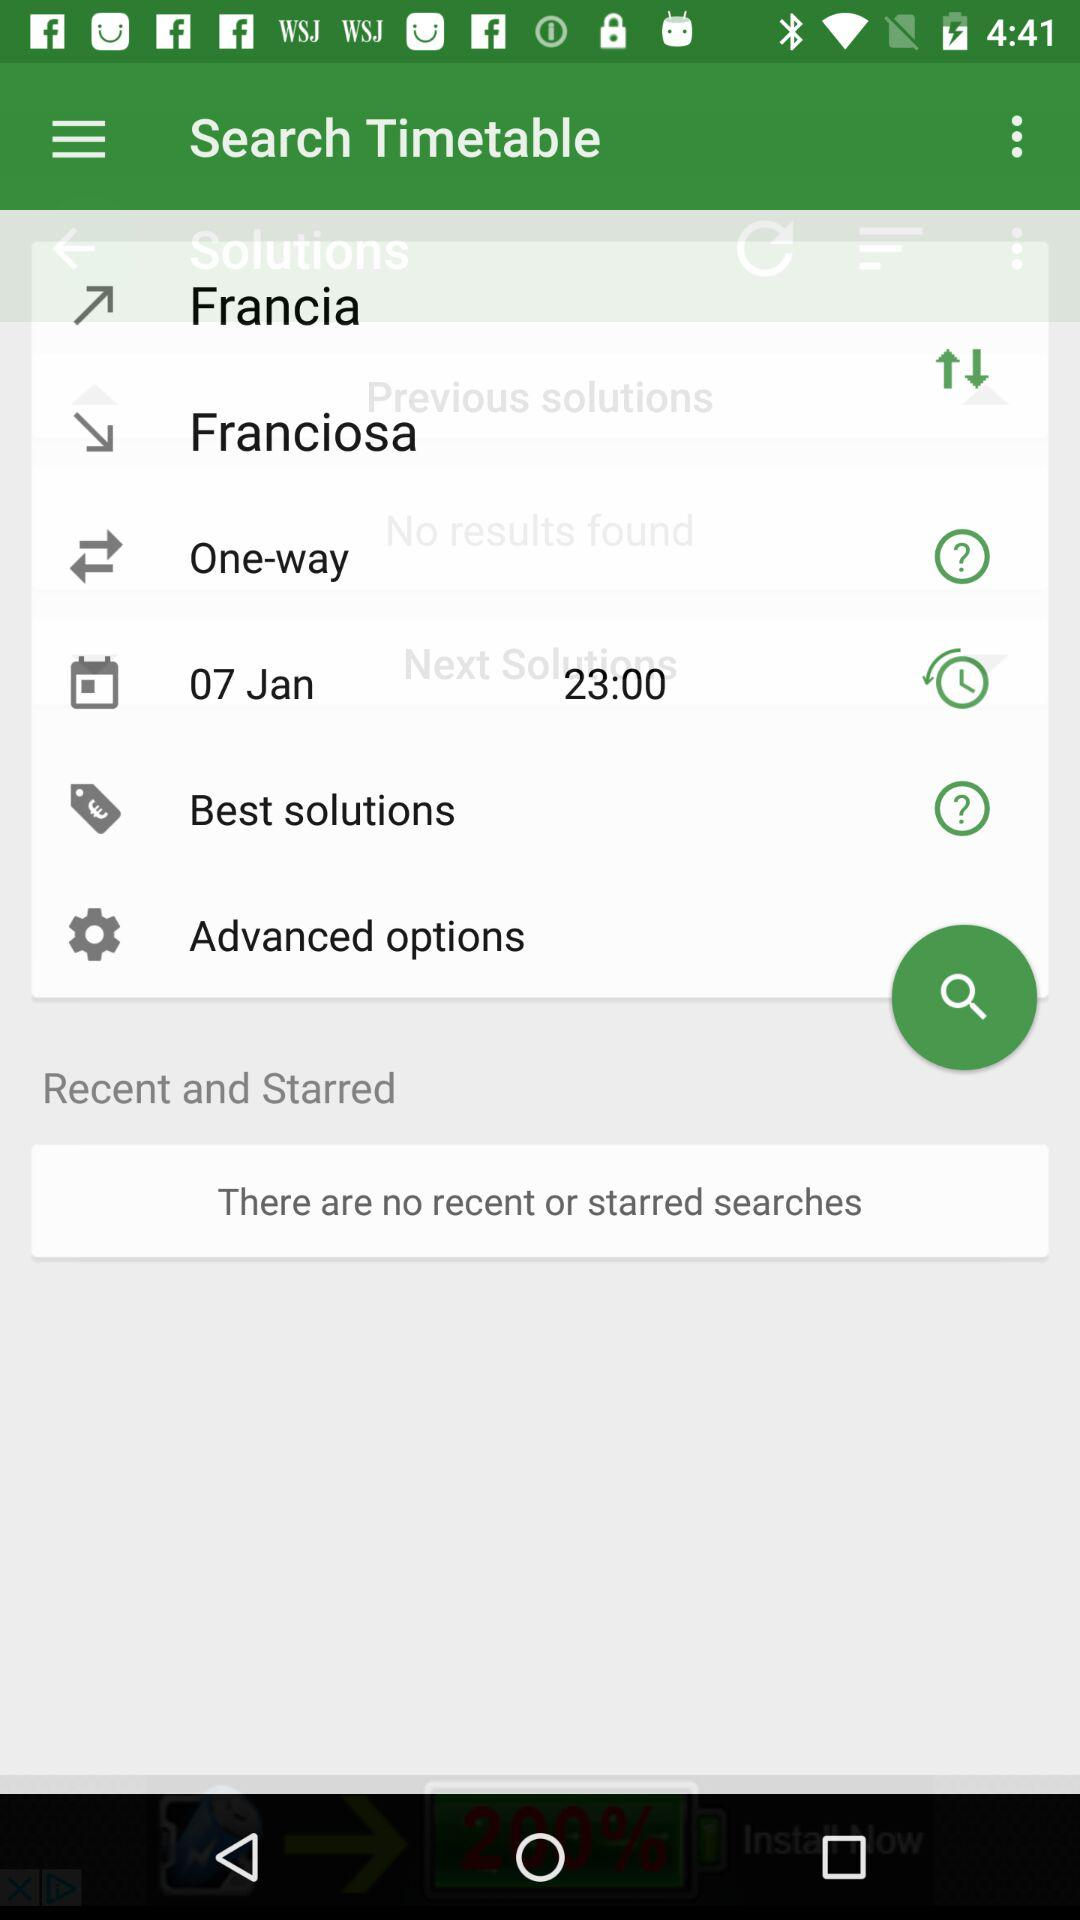What is the pickup location? The pickup location is Francia. 